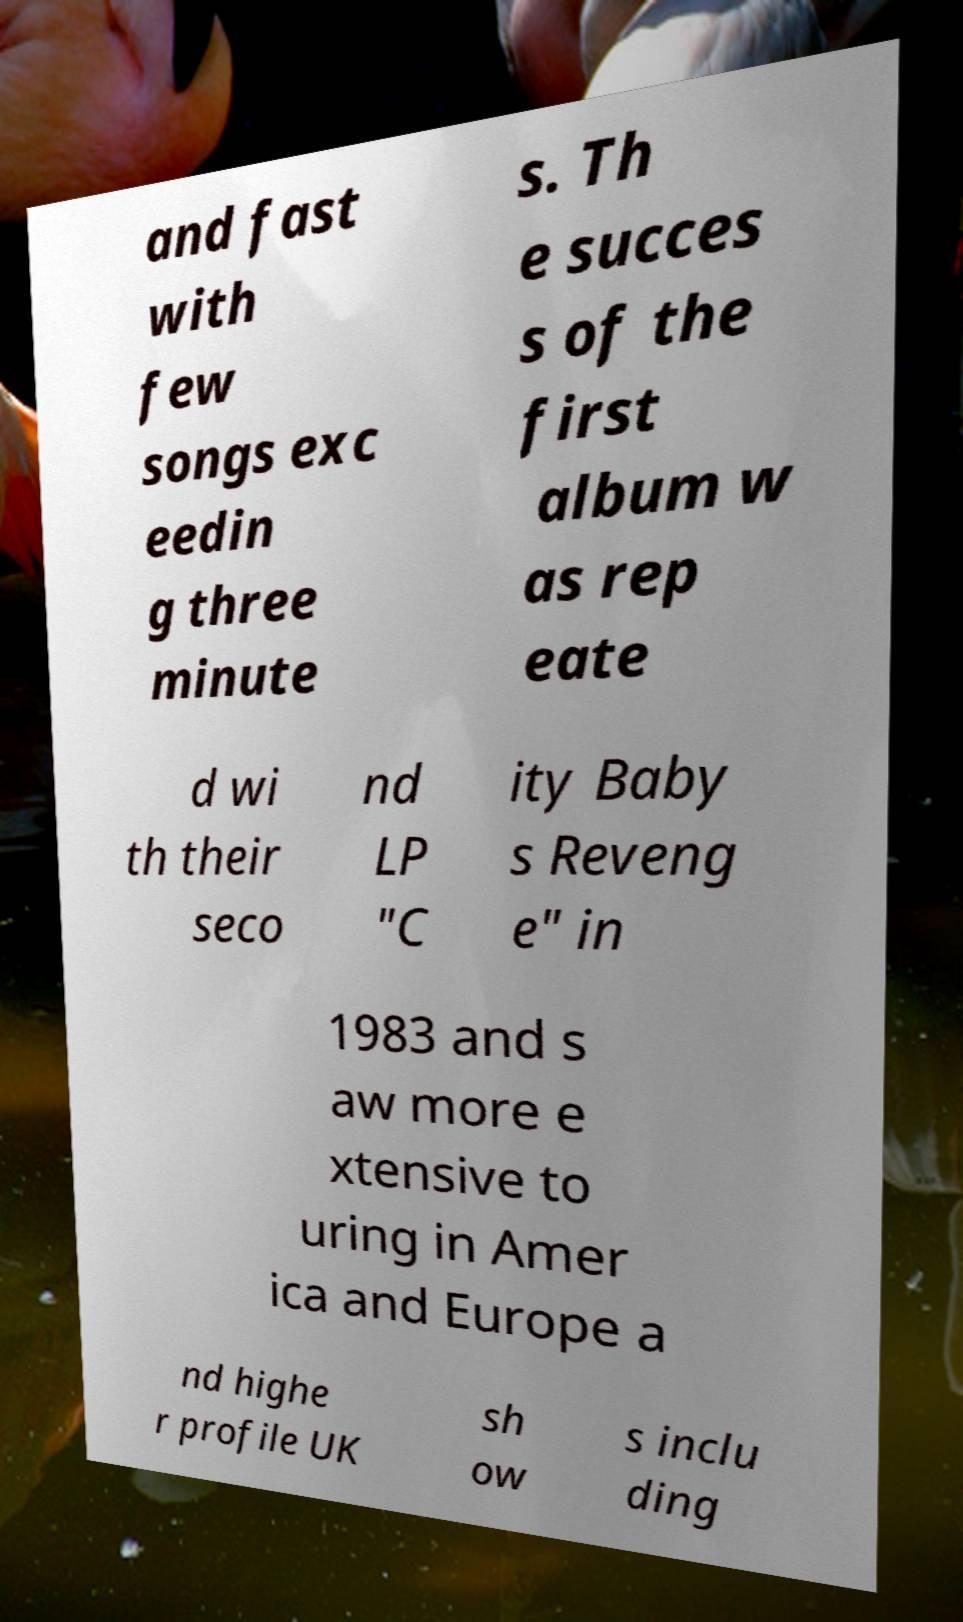There's text embedded in this image that I need extracted. Can you transcribe it verbatim? and fast with few songs exc eedin g three minute s. Th e succes s of the first album w as rep eate d wi th their seco nd LP "C ity Baby s Reveng e" in 1983 and s aw more e xtensive to uring in Amer ica and Europe a nd highe r profile UK sh ow s inclu ding 